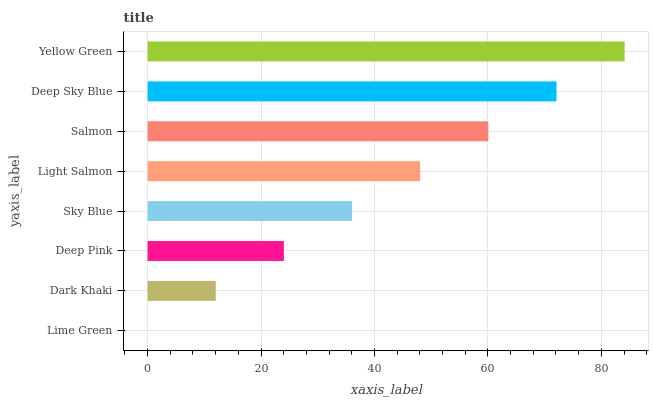Is Lime Green the minimum?
Answer yes or no. Yes. Is Yellow Green the maximum?
Answer yes or no. Yes. Is Dark Khaki the minimum?
Answer yes or no. No. Is Dark Khaki the maximum?
Answer yes or no. No. Is Dark Khaki greater than Lime Green?
Answer yes or no. Yes. Is Lime Green less than Dark Khaki?
Answer yes or no. Yes. Is Lime Green greater than Dark Khaki?
Answer yes or no. No. Is Dark Khaki less than Lime Green?
Answer yes or no. No. Is Light Salmon the high median?
Answer yes or no. Yes. Is Sky Blue the low median?
Answer yes or no. Yes. Is Dark Khaki the high median?
Answer yes or no. No. Is Lime Green the low median?
Answer yes or no. No. 